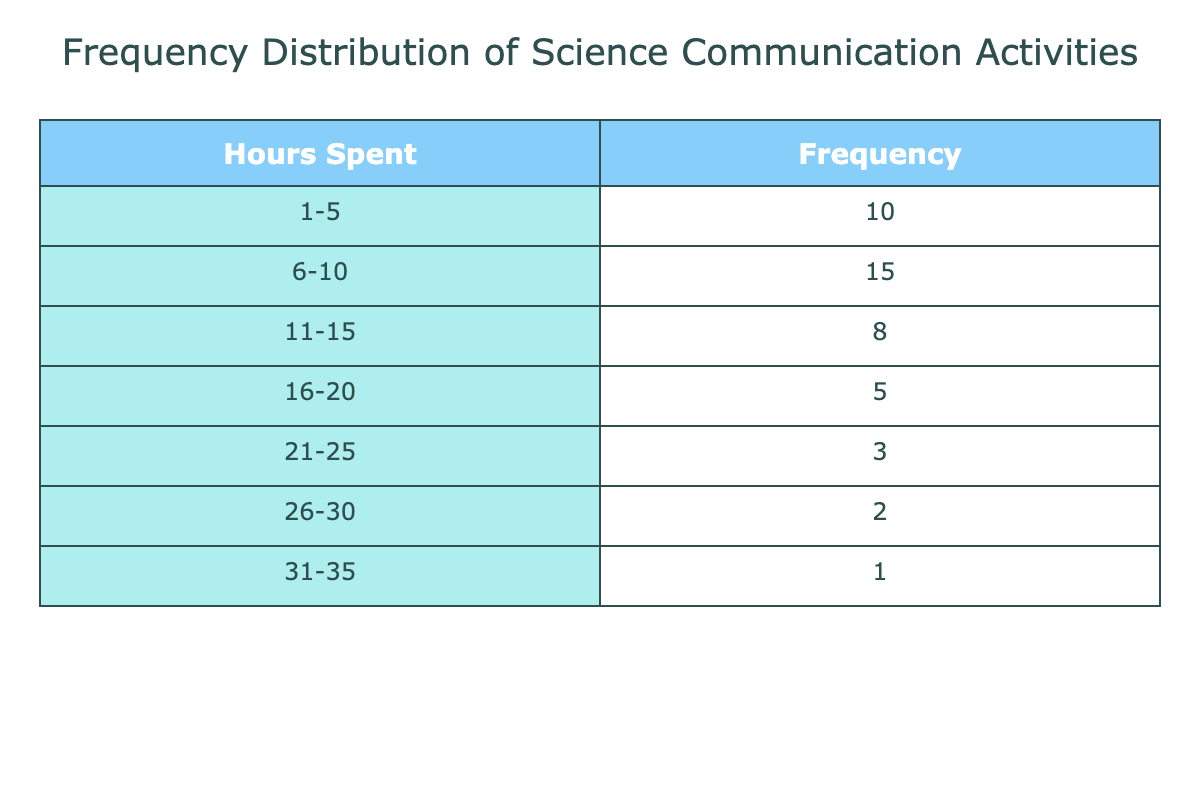What is the frequency of science writers spending 6-10 hours on communication activities? Referring directly to the table, the frequency of the range 6-10 hours is listed as 15.
Answer: 15 What is the total number of science writers surveyed based on this table? To find the total number of science writers, we add the frequencies for all the hours: 10 + 15 + 8 + 5 + 3 + 2 + 1 = 44.
Answer: 44 Is it true that more than half of the surveyed science writers spend 10 hours or less on communication activities? The number of writers spending 0-10 hours is 10 (1-5 hours) + 15 (6-10 hours) = 25. Since the total is 44, 25 is indeed more than half of 44, which is 22.
Answer: Yes What is the average number of hours spent by the science writers in the category of 11-15 hours? The mid-point of 11-15 hours is 13 hours. The frequency for this category is 8. Therefore, on average, 8 science writers spend about 13 hours per week.
Answer: 13 How many more science writers spend 1-5 hours on communication activities compared to those spending 21-25 hours? The number of writers in the 1-5 hours range is 10, while in the 21-25 hours range it is 3. The difference is 10 - 3 = 7 writers.
Answer: 7 How many science writers spend more than 20 hours on communication activities? To find this, we add the frequencies for the ranges 21-25, 26-30, and 31-35: 3 + 2 + 1 = 6.
Answer: 6 What percentage of science writers spend between 16-20 hours on communication activities? The number of writers in the 16-20 hours range is 5. To find the percentage, we calculate (5/44) * 100, which equals approximately 11.36%.
Answer: 11.36% How does the frequency of writers spending 26-30 hours compare to those spending 11-15 hours? The frequency in the 26-30 hours range is 2 and in the 11-15 hours range is 8. Therefore, there are 8 - 2 = 6 more writers in the 11-15 hour category.
Answer: 6 more writers in 11-15 hours What is the combined frequency of science writers spending 1-10 hours compared to those spending over 20 hours? The combined frequency for 1-10 hours is 10 + 15 = 25, while the frequency for over 20 hours (21-25, 26-30, and 31-35) is 3 + 2 + 1 = 6. So 25 is greater than 6 by 19.
Answer: 19 more 